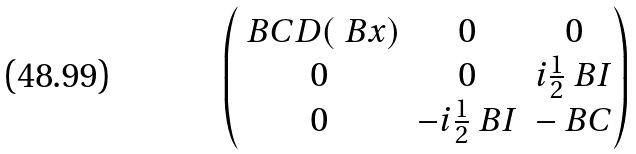<formula> <loc_0><loc_0><loc_500><loc_500>\begin{pmatrix} \ B C D ( \ B x ) & 0 & 0 \\ 0 & 0 & i \frac { 1 } { 2 } \ B I \\ 0 & - i \frac { 1 } { 2 } \ B I & - \ B C \end{pmatrix}</formula> 